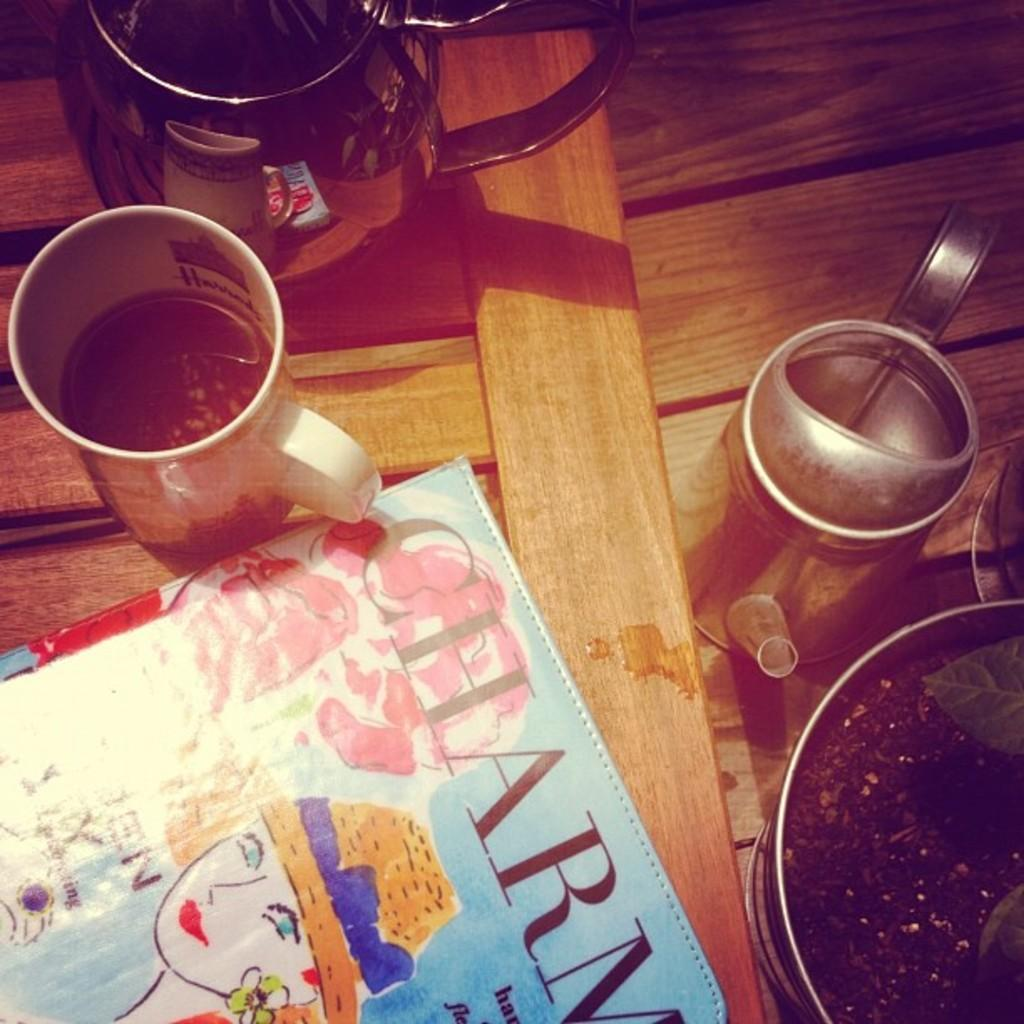What piece of furniture is present in the image? There is a table in the image. What items can be seen on the table? There is a kettle, a jug, a coffee mug, a houseplant, and a book on the table. What might be used for heating water in the image? The kettle on the table might be used for heating water. What could be used for holding a beverage in the image? The coffee mug on the table could be used for holding a beverage. What type of story is being discussed by the characters in the image? There are no characters present in the image, and no story is being discussed. Where is the faucet located in the image? There is no faucet present in the image. 